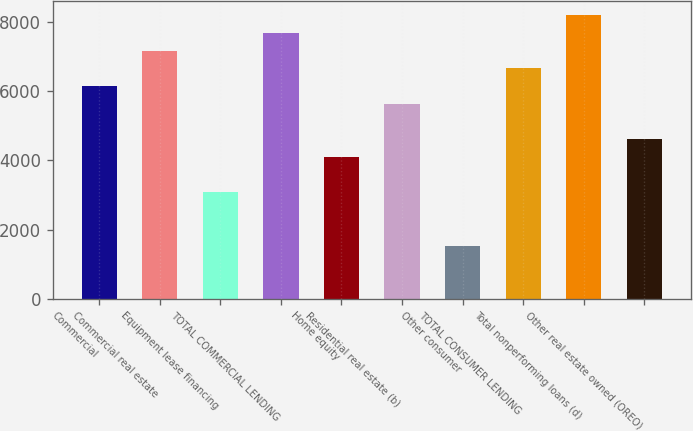<chart> <loc_0><loc_0><loc_500><loc_500><bar_chart><fcel>Commercial<fcel>Commercial real estate<fcel>Equipment lease financing<fcel>TOTAL COMMERCIAL LENDING<fcel>Home equity<fcel>Residential real estate (b)<fcel>Other consumer<fcel>TOTAL CONSUMER LENDING<fcel>Total nonperforming loans (d)<fcel>Other real estate owned (OREO)<nl><fcel>6147.26<fcel>7171.48<fcel>3074.6<fcel>7683.59<fcel>4098.82<fcel>5635.15<fcel>1538.27<fcel>6659.37<fcel>8195.7<fcel>4610.93<nl></chart> 